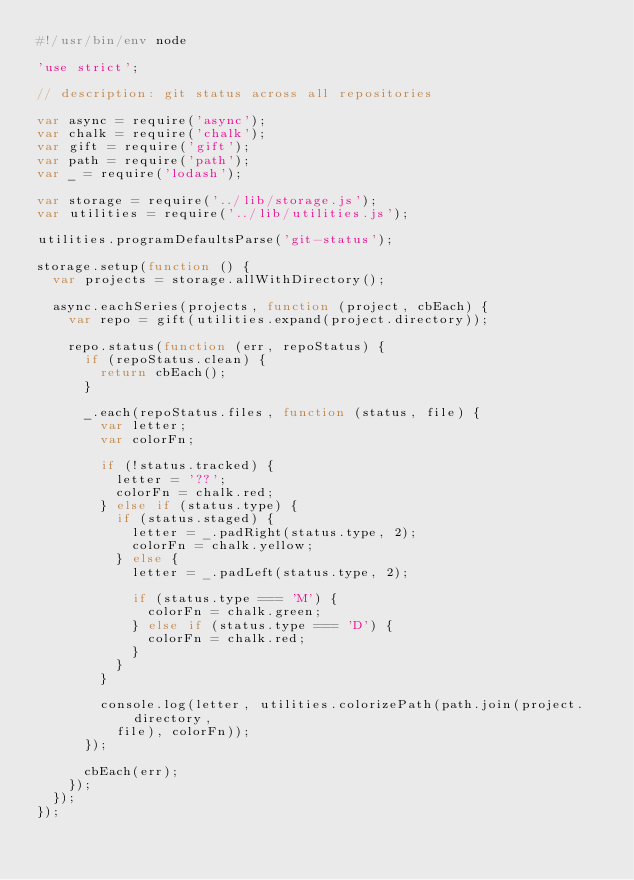<code> <loc_0><loc_0><loc_500><loc_500><_JavaScript_>#!/usr/bin/env node

'use strict';

// description: git status across all repositories

var async = require('async');
var chalk = require('chalk');
var gift = require('gift');
var path = require('path');
var _ = require('lodash');

var storage = require('../lib/storage.js');
var utilities = require('../lib/utilities.js');

utilities.programDefaultsParse('git-status');

storage.setup(function () {
  var projects = storage.allWithDirectory();

  async.eachSeries(projects, function (project, cbEach) {
    var repo = gift(utilities.expand(project.directory));

    repo.status(function (err, repoStatus) {
      if (repoStatus.clean) {
        return cbEach();
      }

      _.each(repoStatus.files, function (status, file) {
        var letter;
        var colorFn;

        if (!status.tracked) {
          letter = '??';
          colorFn = chalk.red;
        } else if (status.type) {
          if (status.staged) {
            letter = _.padRight(status.type, 2);
            colorFn = chalk.yellow;
          } else {
            letter = _.padLeft(status.type, 2);

            if (status.type === 'M') {
              colorFn = chalk.green;
            } else if (status.type === 'D') {
              colorFn = chalk.red;
            }
          }
        }

        console.log(letter, utilities.colorizePath(path.join(project.directory,
          file), colorFn));
      });

      cbEach(err);
    });
  });
});
</code> 